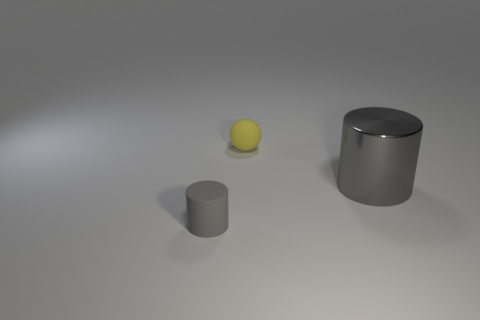Add 3 big purple things. How many objects exist? 6 Subtract all balls. How many objects are left? 2 Subtract all tiny spheres. Subtract all gray matte cylinders. How many objects are left? 1 Add 2 small matte cylinders. How many small matte cylinders are left? 3 Add 2 purple rubber things. How many purple rubber things exist? 2 Subtract 2 gray cylinders. How many objects are left? 1 